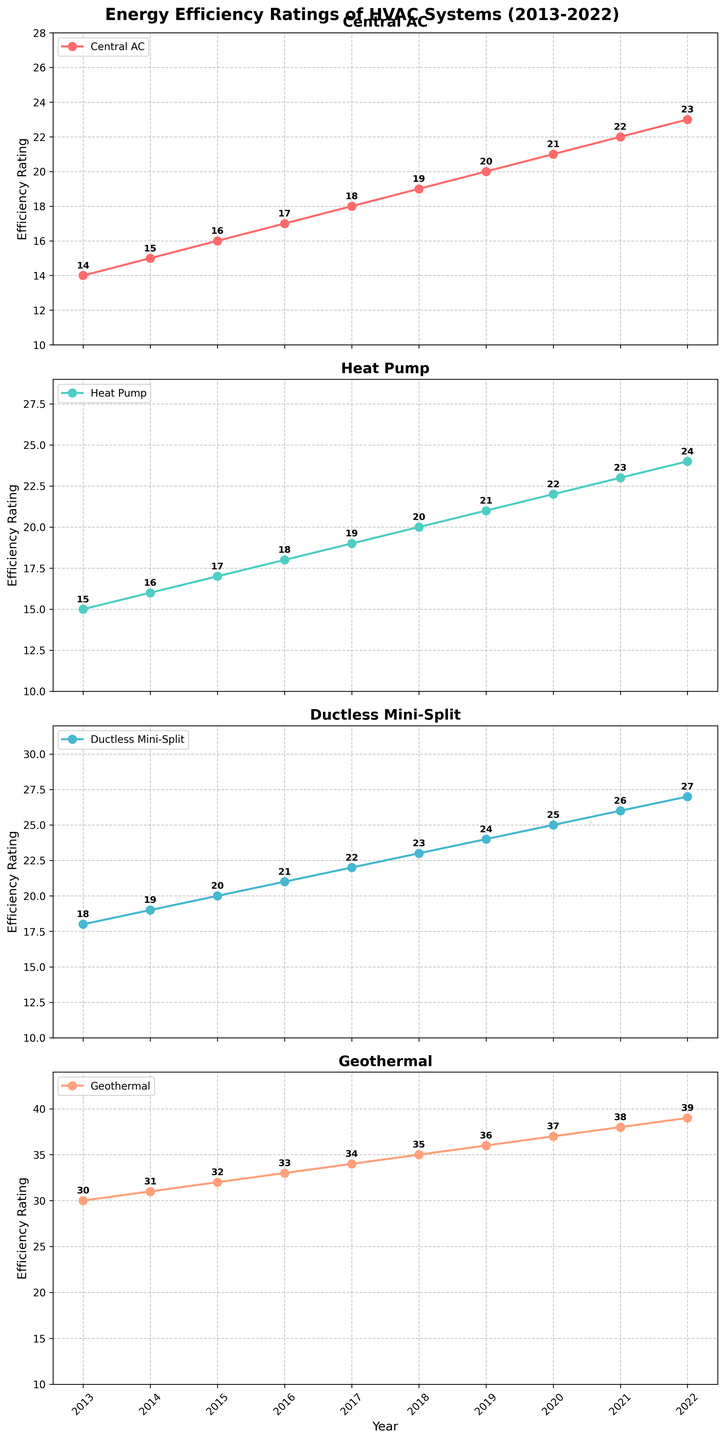What's the average energy efficiency rating for the Central AC system over the decade? To calculate the average, sum the efficiency ratings from 2013 to 2022 (14+15+16+17+18+19+20+21+22+23) = 185, then divide by the number of years (10). The average is 185/10 = 18.5
Answer: 18.5 Which HVAC system had the highest efficiency rating in 2020? By examining the chart for the year 2020, we see the ratings: Central AC (21), Heat Pump (22), Ductless Mini-Split (25), and Geothermal (37). Geothermal had the highest rating.
Answer: Geothermal What is the difference in efficiency ratings between Geothermal and Ductless Mini-Split systems in 2018? In 2018, the efficiency rating for Geothermal is 35, and for Ductless Mini-Split is 23. The difference is 35 - 23.
Answer: 12 Which year saw the same efficiency rating for Heat Pump and Ductless Mini-Split systems? By inspecting the graphs, we can see that in 2016, the Heat Pump had a rating of 18, and the Ductless Mini-Split also had a rating of 18.
Answer: 2016 How much did the efficiency rating for Central AC increase from 2013 to 2022? The rating for Central AC was 14 in 2013 and 23 in 2022. The increase is 23 - 14.
Answer: 9 By how much did the efficiency rating of the Ductless Mini-Split system increase in 2022 compared to 2013? In 2013, the Ductless Mini-Split system's rating was 18, and in 2022, it was 27. The increase is 27 - 18.
Answer: 9 Compare the efficiency rating trends of Central AC and Heat Pump systems over the decade. Which system had a steeper growth? To determine this, we compare the differences in ratings over the decade: Central AC increased from 14 to 23 (9 units) and Heat Pump from 15 to 24 (9 units). Both systems grew the same amount in absolute terms.
Answer: Both had the same growth Which HVAC system showed the most consistent increase in efficiency rating each year? By inspecting the graphs, we see that each system shows a consistent upward trend but the Geothermal system shows a steady increase by 1 every year.
Answer: Geothermal What's the range of efficiency ratings for the Geothermal system over the past decade? The smallest rating for Geothermal was in 2013 (30) and the highest in 2022 (39). The range is 39 - 30.
Answer: 9 